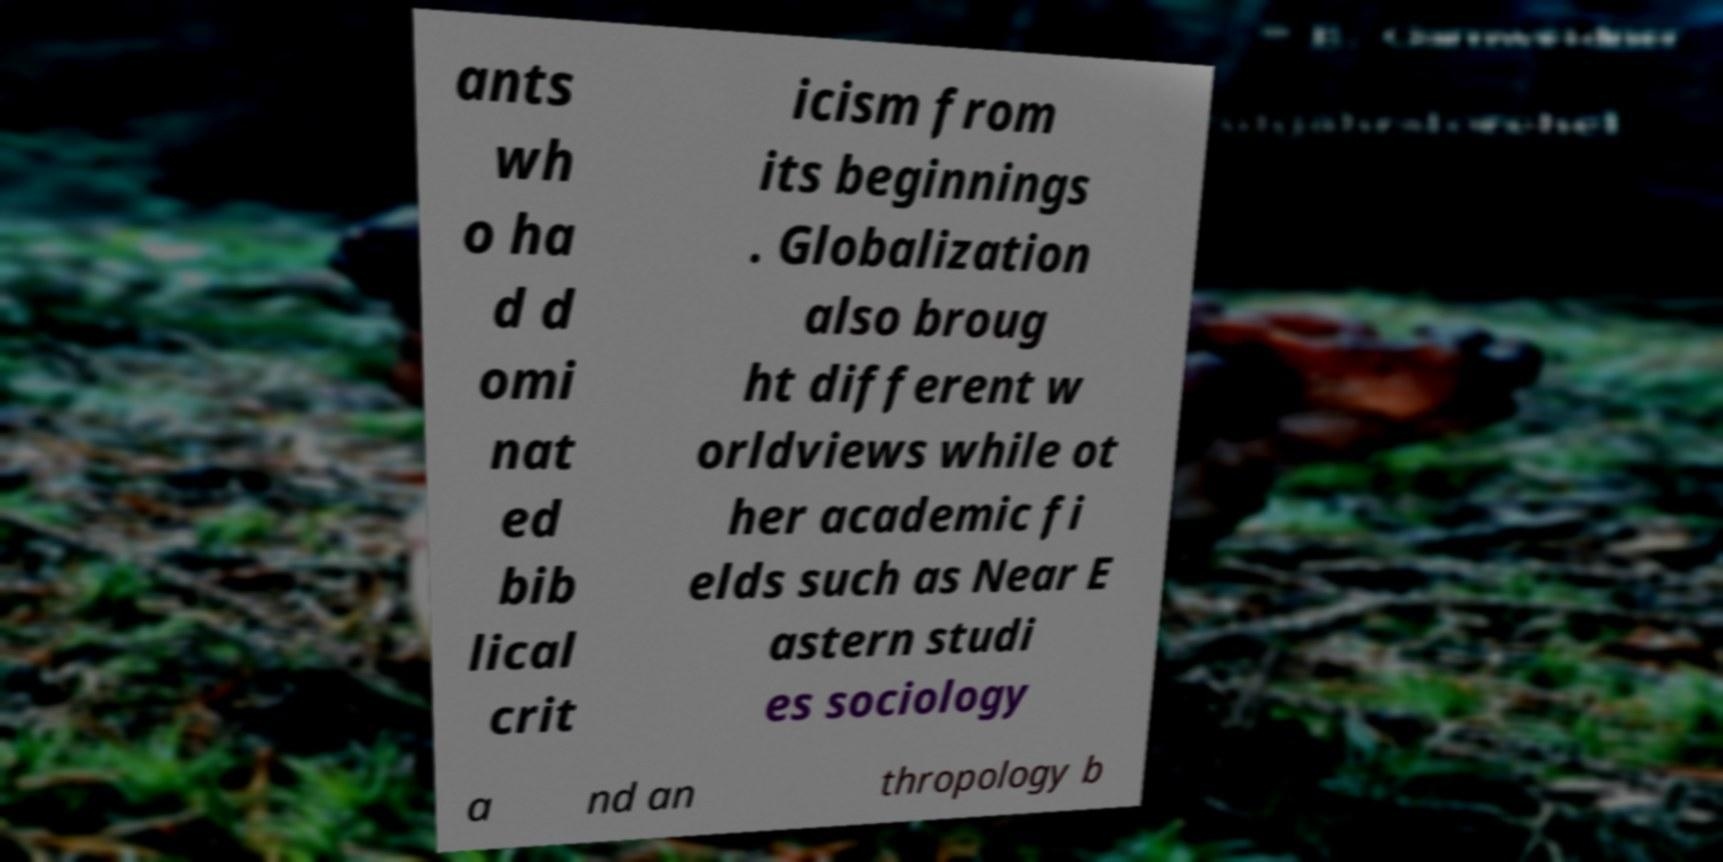Can you read and provide the text displayed in the image?This photo seems to have some interesting text. Can you extract and type it out for me? ants wh o ha d d omi nat ed bib lical crit icism from its beginnings . Globalization also broug ht different w orldviews while ot her academic fi elds such as Near E astern studi es sociology a nd an thropology b 